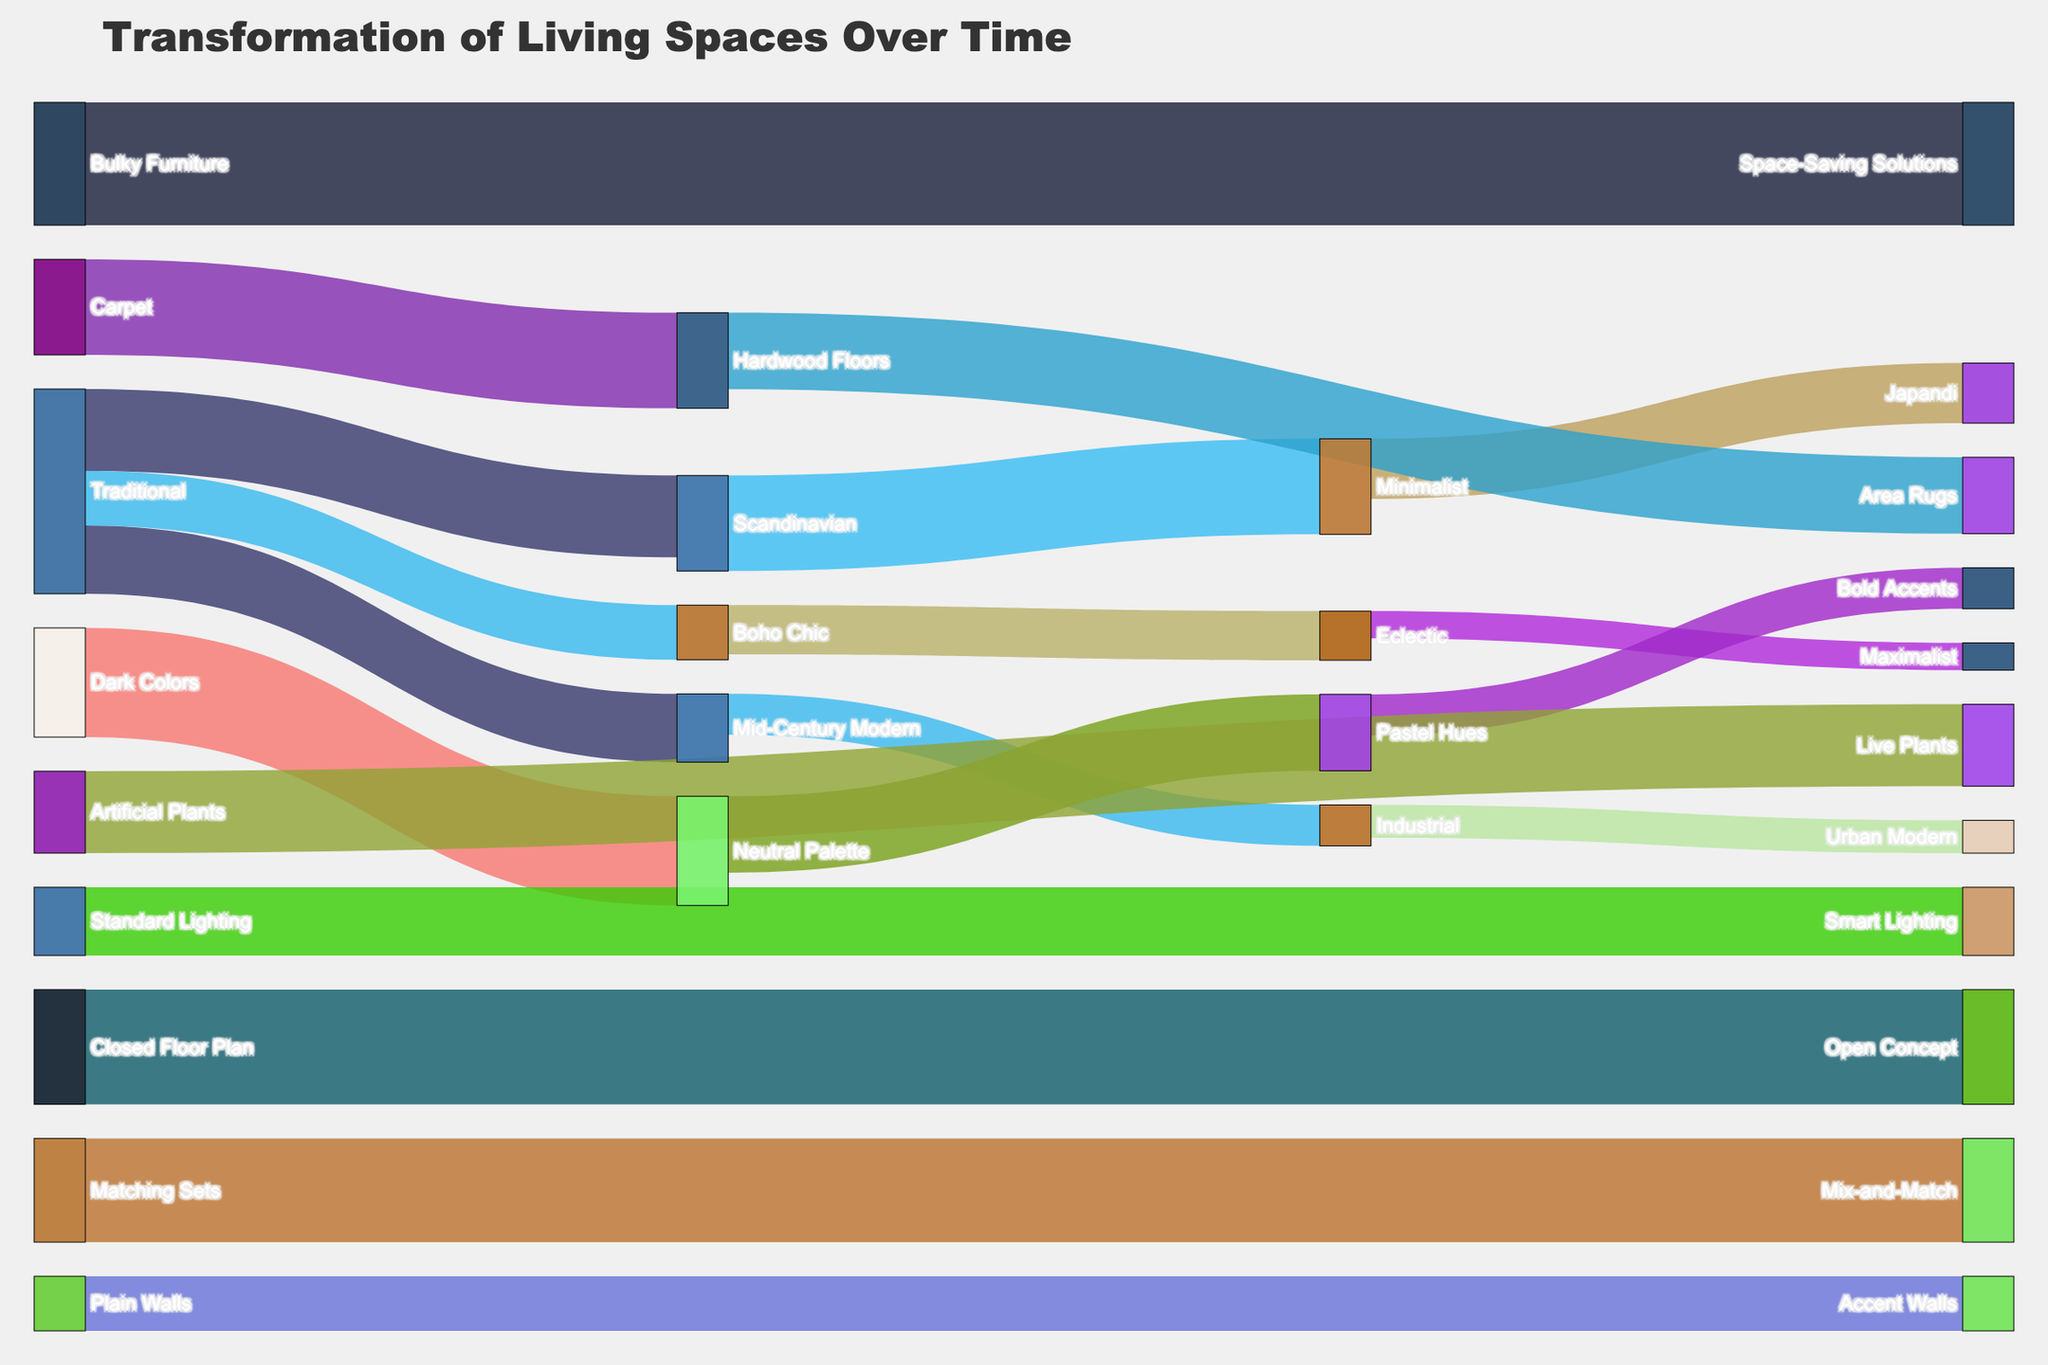What is the title of the Sankey diagram? The title of the Sankey diagram is usually displayed at the top, prominently.
Answer: Transformation of Living Spaces Over Time What transformation has the highest value in the diagram? By looking at the values linked to the flows in the diagram, we can identify the highest value. The transformation from "Bulky Furniture" to "Space-Saving Solutions" has the highest value of 45.
Answer: Bulky Furniture to Space-Saving Solutions Which design style changes to "Minimalist" and what is the value of this change? Use the links that lead to "Minimalist" and check the source and the corresponding value listed in the diagram. The style "Scandinavian" changes to "Minimalist" with a value of 35.
Answer: Scandinavian to Minimalist, 35 How many transformations involve "Hardwood Floors"? Count the number of links in the Sankey diagram that either originate from or lead to "Hardwood Floors". There are two transformations: from "Carpet" to "Hardwood Floors" (35) and from "Hardwood Floors" to "Area Rugs" (28).
Answer: 2 Which transformation has the smallest value listed and what is the value? Scan through all the values listed for each link in the Sankey diagram to find the smallest one. The transformation from "Eclectic" to "Maximalist" has the smallest value of 10.
Answer: Eclectic to Maximalist, 10 Compare the values for transformations involving lighting. Which has a higher value, "Standard Lighting" to "Smart Lighting" or "Plain Walls" to "Accent Walls"? Identify the values for each of the two transformations involving lighting and compare them. "Standard Lighting" to "Smart Lighting" has a value of 25, whereas "Plain Walls" to "Accent Walls" has a value of 20. Therefore, "Standard Lighting" to "Smart Lighting" has a higher value.
Answer: Standard Lighting to Smart Lighting How many design style transformations start from "Traditional"? Count the number of links that originate from the node "Traditional" in the Sankey diagram. There are three transformations starting from "Traditional": to "Scandinavian" (30), to "Mid-Century Modern" (25), and to "Boho Chic" (20).
Answer: 3 What is the total value of transformations ending in styles under "Eclectic"? Add up the values of the transformations that lead into the target "Eclectic". The total value is from "Boho Chic" (18) plus "Maximalist" (10) which equals 28.
Answer: 28 What is the combined value of transformations related to color schemes? Add the values of all transformations related to color schemes: "Dark Colors" to "Neutral Palette" (40), "Neutral Palette" to "Pastel Hues" (28), and "Pastel Hues" to "Bold Accents" (15). Therefore, the combined value is 40 + 28 + 15 = 83.
Answer: 83 Which transformation related to flooring has the higher value: from "Carpet" to "Hardwood Floors" or from "Hardwood Floors" to "Area Rugs"? Compare the values of the two transformations by checking their respective links. "Carpet" to "Hardwood Floors" has a value of 35, while "Hardwood Floors" to "Area Rugs" has a value of 28. Hence, "Carpet" to "Hardwood Floors" has the higher value.
Answer: Carpet to Hardwood Floors 